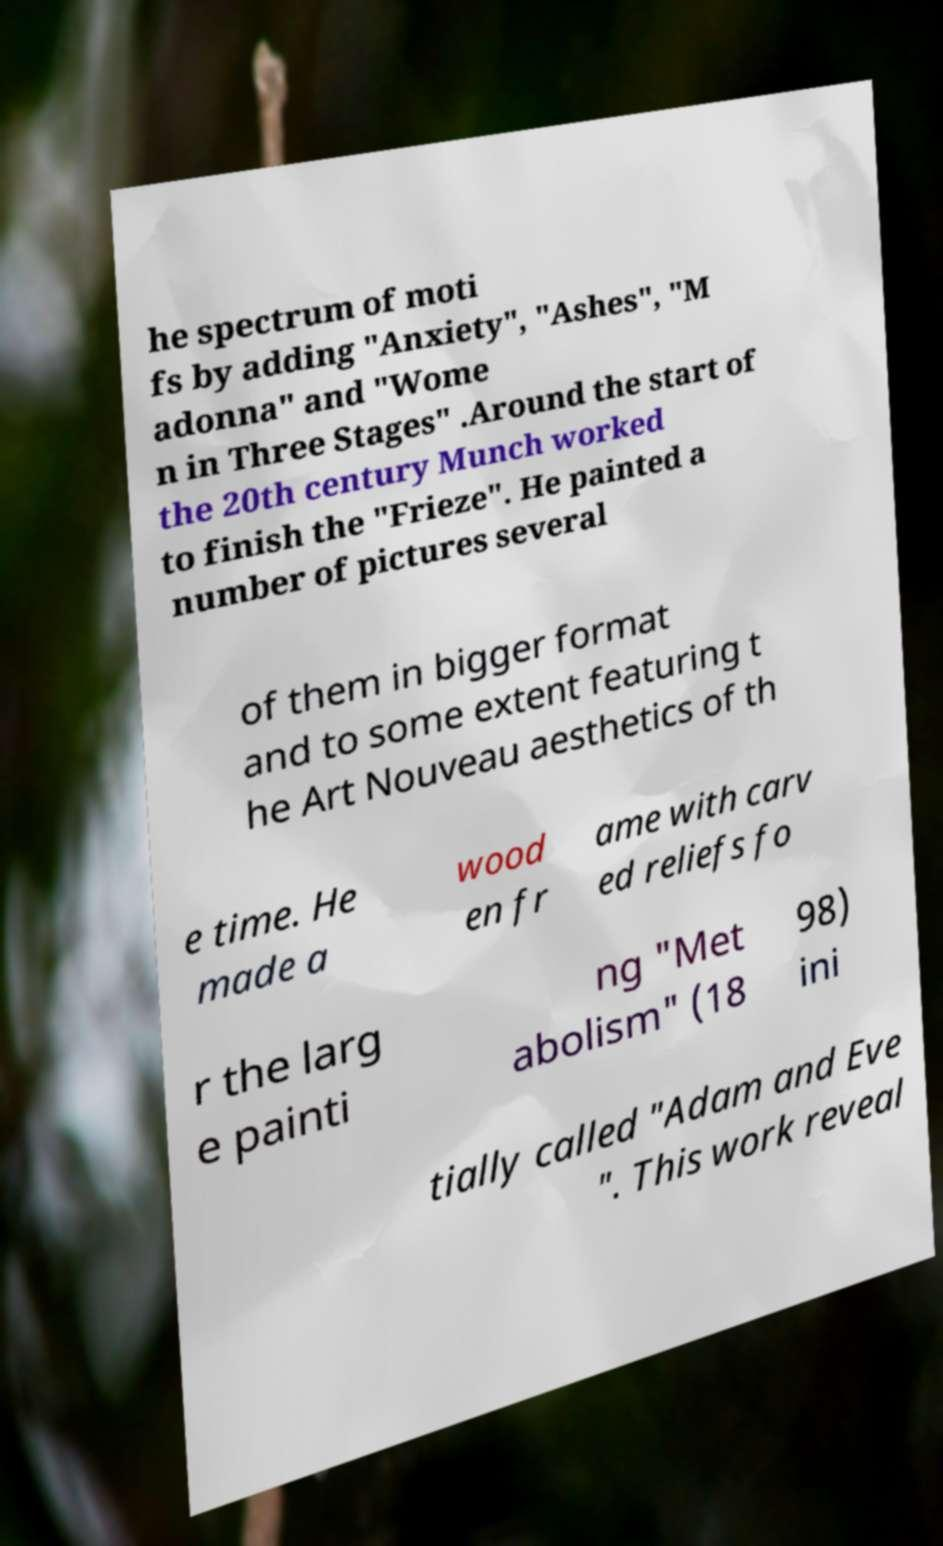I need the written content from this picture converted into text. Can you do that? he spectrum of moti fs by adding "Anxiety", "Ashes", "M adonna" and "Wome n in Three Stages" .Around the start of the 20th century Munch worked to finish the "Frieze". He painted a number of pictures several of them in bigger format and to some extent featuring t he Art Nouveau aesthetics of th e time. He made a wood en fr ame with carv ed reliefs fo r the larg e painti ng "Met abolism" (18 98) ini tially called "Adam and Eve ". This work reveal 